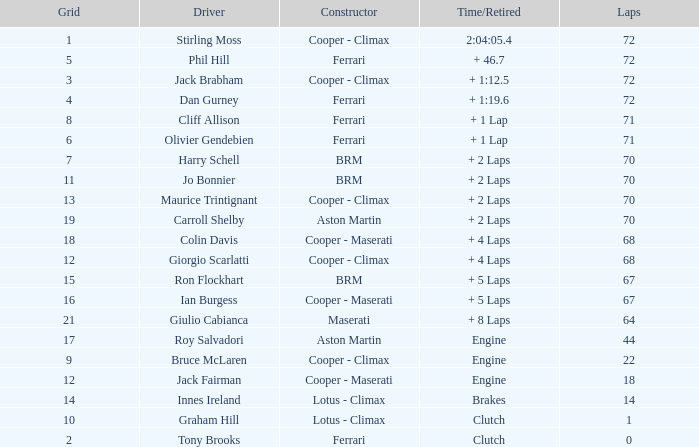What is the time/retired for phil hill with over 67 laps and a grad smaller than 18? + 46.7. 